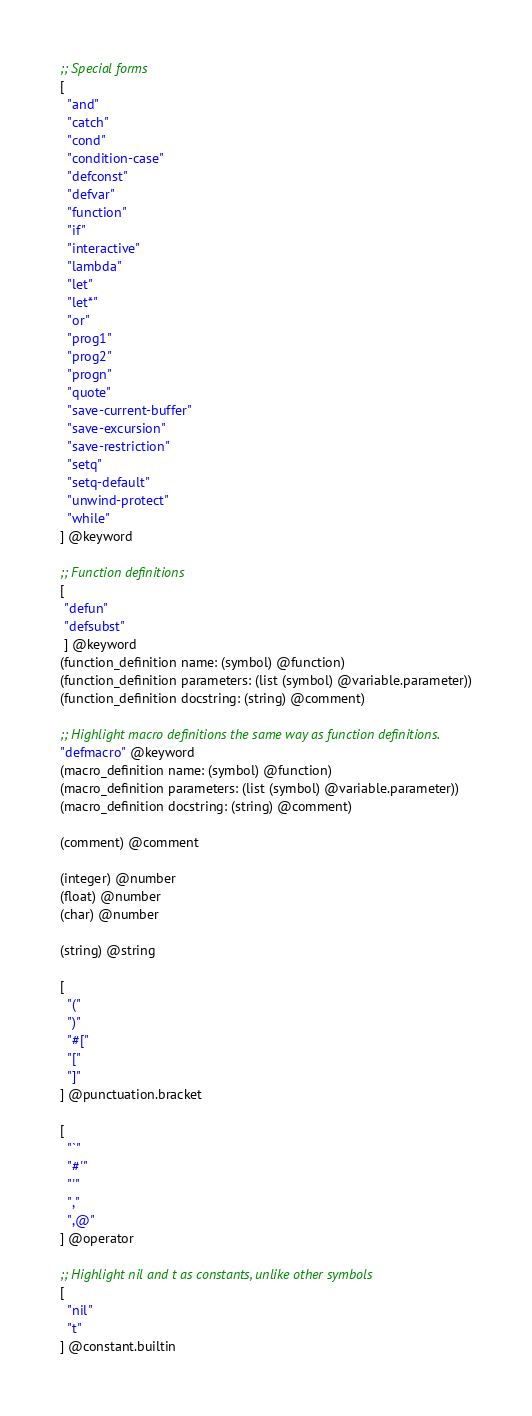<code> <loc_0><loc_0><loc_500><loc_500><_Scheme_>;; Special forms
[
  "and"
  "catch"
  "cond"
  "condition-case"
  "defconst"
  "defvar"
  "function"
  "if"
  "interactive"
  "lambda"
  "let"
  "let*"
  "or"
  "prog1"
  "prog2"
  "progn"
  "quote"
  "save-current-buffer"
  "save-excursion"
  "save-restriction"
  "setq"
  "setq-default"
  "unwind-protect"
  "while"
] @keyword

;; Function definitions
[
 "defun"
 "defsubst"
 ] @keyword
(function_definition name: (symbol) @function)
(function_definition parameters: (list (symbol) @variable.parameter))
(function_definition docstring: (string) @comment)

;; Highlight macro definitions the same way as function definitions.
"defmacro" @keyword
(macro_definition name: (symbol) @function)
(macro_definition parameters: (list (symbol) @variable.parameter))
(macro_definition docstring: (string) @comment)

(comment) @comment

(integer) @number
(float) @number
(char) @number

(string) @string

[
  "("
  ")"
  "#["
  "["
  "]"
] @punctuation.bracket

[
  "`"
  "#'"
  "'"
  ","
  ",@"
] @operator

;; Highlight nil and t as constants, unlike other symbols
[
  "nil"
  "t"
] @constant.builtin
</code> 